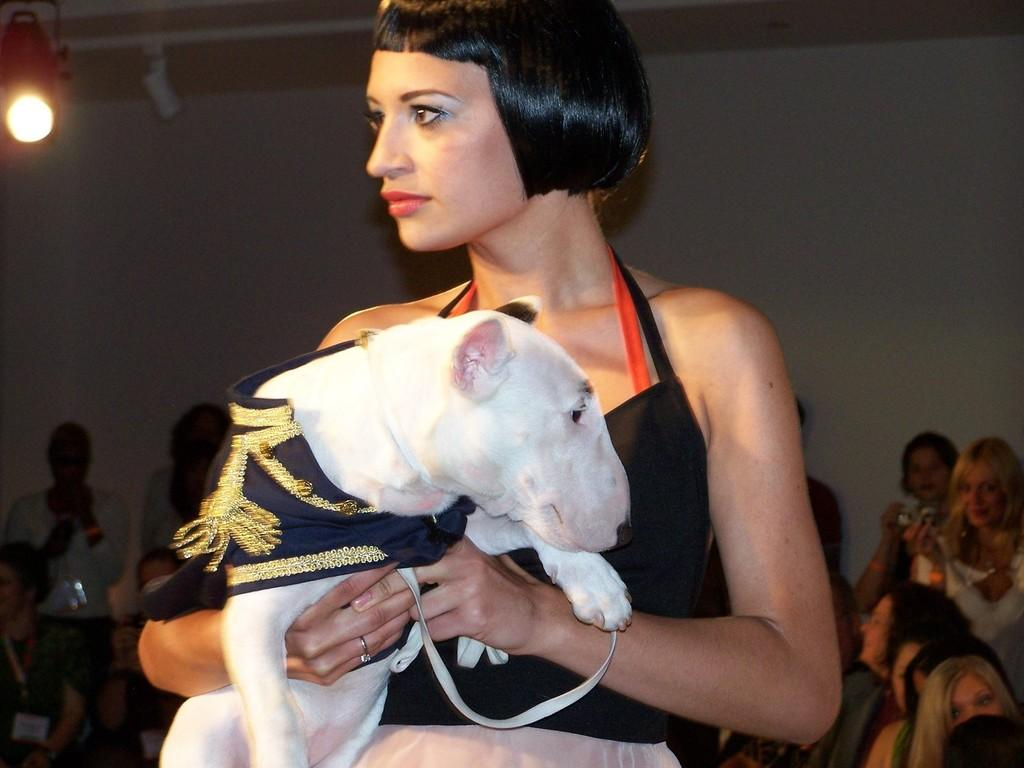Who is the main subject in the image? There is a woman in the image. What is the woman doing in the image? The woman is standing and holding an animal in her hand. Are there any other people in the image? Yes, there are people seated in the image. What are the seated people doing? The seated people are watching the woman. What type of scarf is the woman wearing in the image? There is no mention of a scarf in the image. 